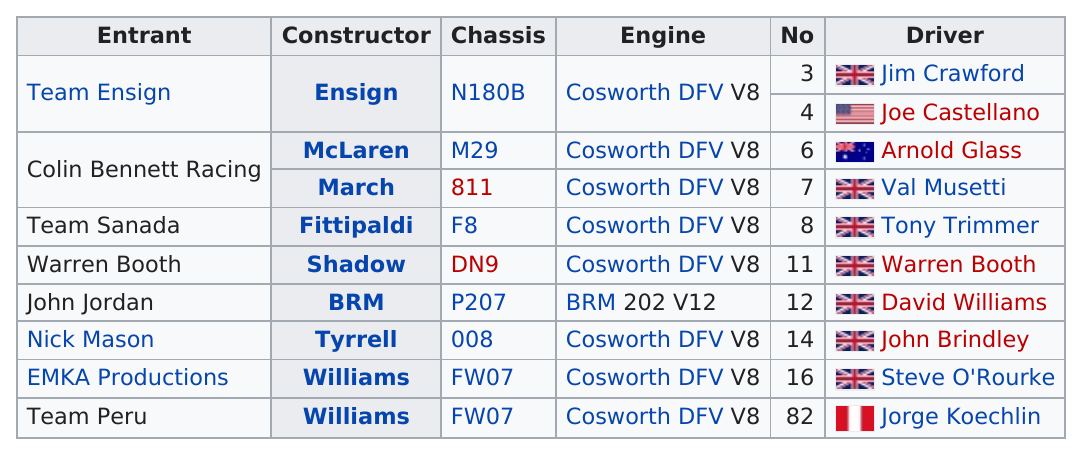Give some essential details in this illustration. It is not the case that any other engines, besides Cosworth or BRM, are listed. Of the entrants, a number of them have names that contain the word "team". The last chassis listed is FW07. A total of 2 vehicles utilized the FW07 chassis. It is a fact that John Jordan is the only driver to have used a v12 engine in his racing career. 